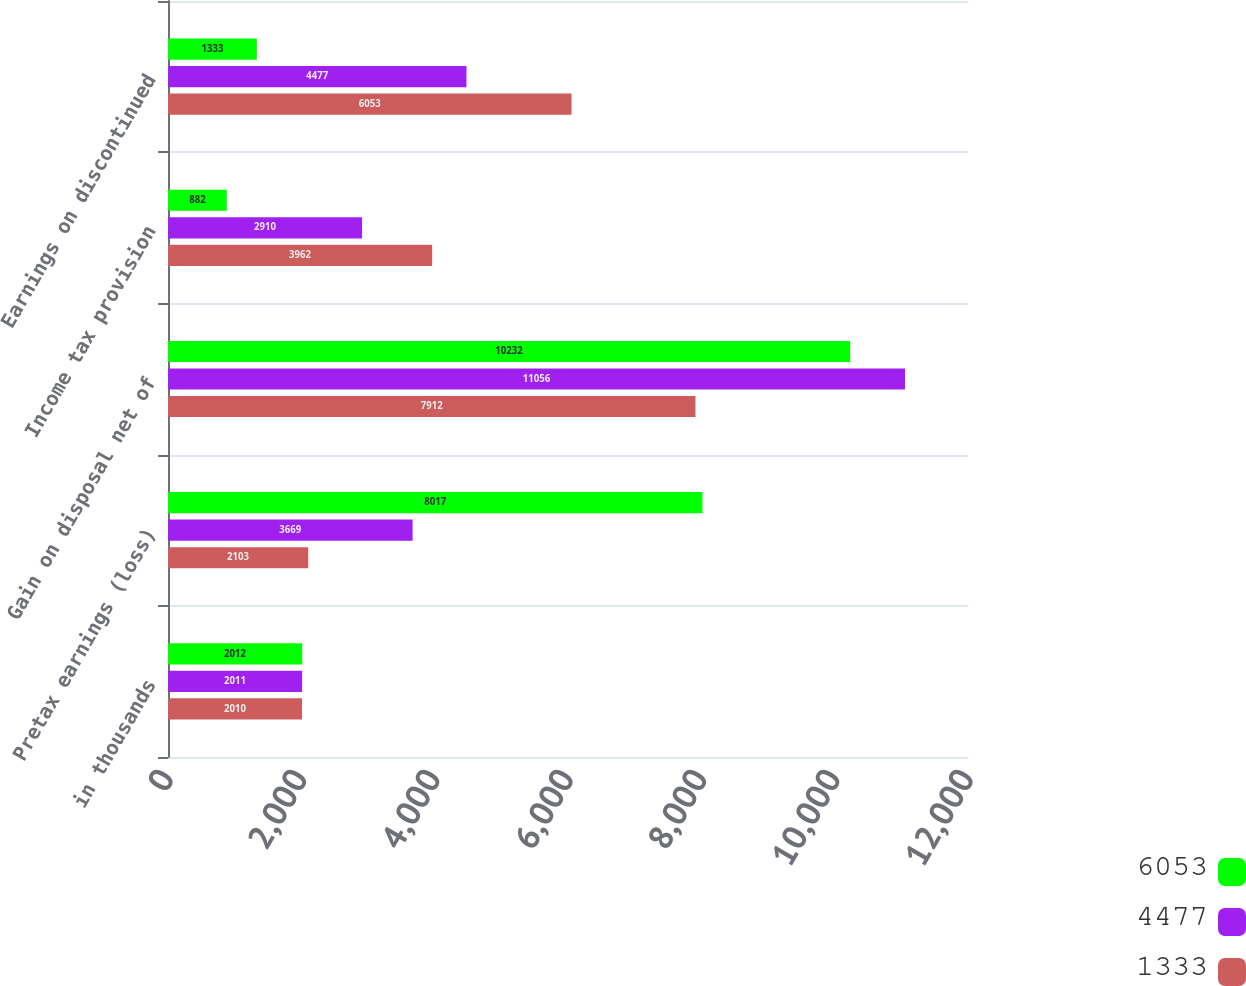<chart> <loc_0><loc_0><loc_500><loc_500><stacked_bar_chart><ecel><fcel>in thousands<fcel>Pretax earnings (loss)<fcel>Gain on disposal net of<fcel>Income tax provision<fcel>Earnings on discontinued<nl><fcel>6053<fcel>2012<fcel>8017<fcel>10232<fcel>882<fcel>1333<nl><fcel>4477<fcel>2011<fcel>3669<fcel>11056<fcel>2910<fcel>4477<nl><fcel>1333<fcel>2010<fcel>2103<fcel>7912<fcel>3962<fcel>6053<nl></chart> 